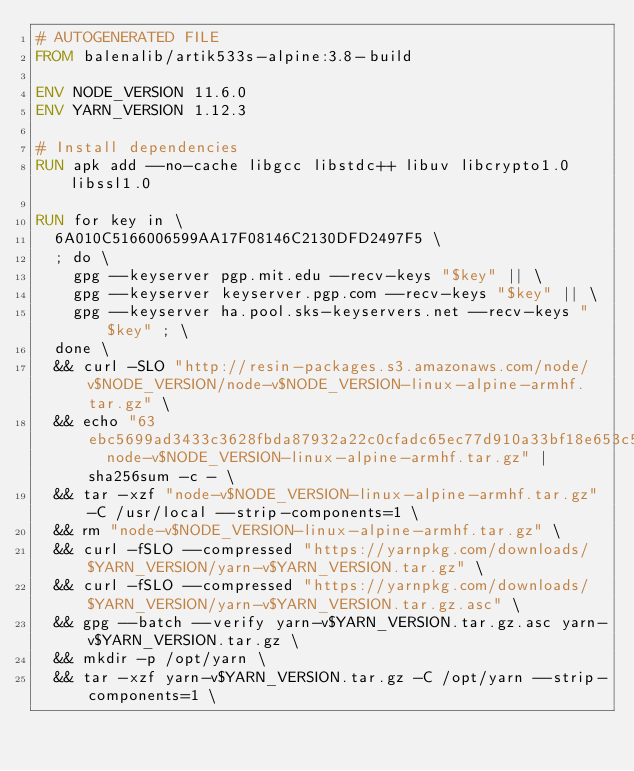<code> <loc_0><loc_0><loc_500><loc_500><_Dockerfile_># AUTOGENERATED FILE
FROM balenalib/artik533s-alpine:3.8-build

ENV NODE_VERSION 11.6.0
ENV YARN_VERSION 1.12.3

# Install dependencies
RUN apk add --no-cache libgcc libstdc++ libuv libcrypto1.0 libssl1.0

RUN for key in \
	6A010C5166006599AA17F08146C2130DFD2497F5 \
	; do \
		gpg --keyserver pgp.mit.edu --recv-keys "$key" || \
		gpg --keyserver keyserver.pgp.com --recv-keys "$key" || \
		gpg --keyserver ha.pool.sks-keyservers.net --recv-keys "$key" ; \
	done \
	&& curl -SLO "http://resin-packages.s3.amazonaws.com/node/v$NODE_VERSION/node-v$NODE_VERSION-linux-alpine-armhf.tar.gz" \
	&& echo "63ebc5699ad3433c3628fbda87932a22c0cfadc65ec77d910a33bf18e653c5b9  node-v$NODE_VERSION-linux-alpine-armhf.tar.gz" | sha256sum -c - \
	&& tar -xzf "node-v$NODE_VERSION-linux-alpine-armhf.tar.gz" -C /usr/local --strip-components=1 \
	&& rm "node-v$NODE_VERSION-linux-alpine-armhf.tar.gz" \
	&& curl -fSLO --compressed "https://yarnpkg.com/downloads/$YARN_VERSION/yarn-v$YARN_VERSION.tar.gz" \
	&& curl -fSLO --compressed "https://yarnpkg.com/downloads/$YARN_VERSION/yarn-v$YARN_VERSION.tar.gz.asc" \
	&& gpg --batch --verify yarn-v$YARN_VERSION.tar.gz.asc yarn-v$YARN_VERSION.tar.gz \
	&& mkdir -p /opt/yarn \
	&& tar -xzf yarn-v$YARN_VERSION.tar.gz -C /opt/yarn --strip-components=1 \</code> 